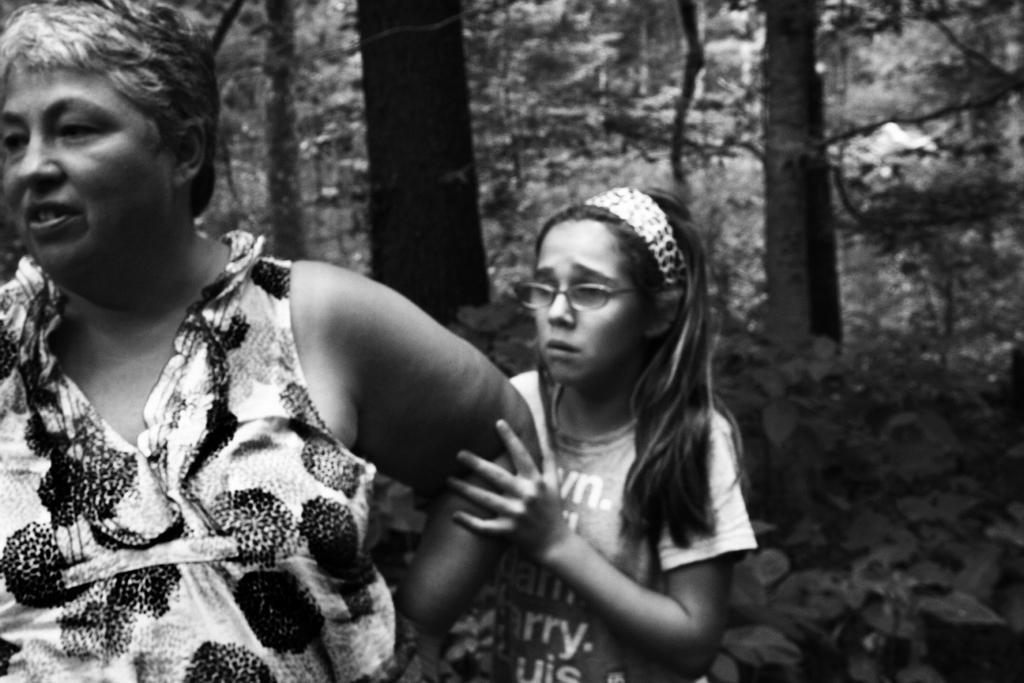Describe this image in one or two sentences. In the center of the image we can see two persons are standing. Among them, we can see a girl is wearing glasses. In the background, we can see trees. 